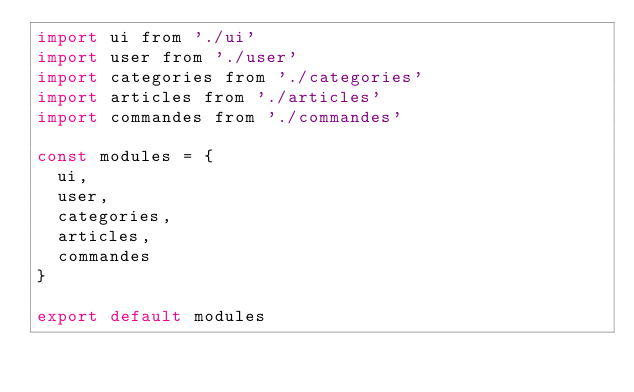<code> <loc_0><loc_0><loc_500><loc_500><_JavaScript_>import ui from './ui'
import user from './user'
import categories from './categories'
import articles from './articles'
import commandes from './commandes'

const modules = {
  ui,
  user,
  categories,
  articles,
  commandes
}

export default modules
</code> 